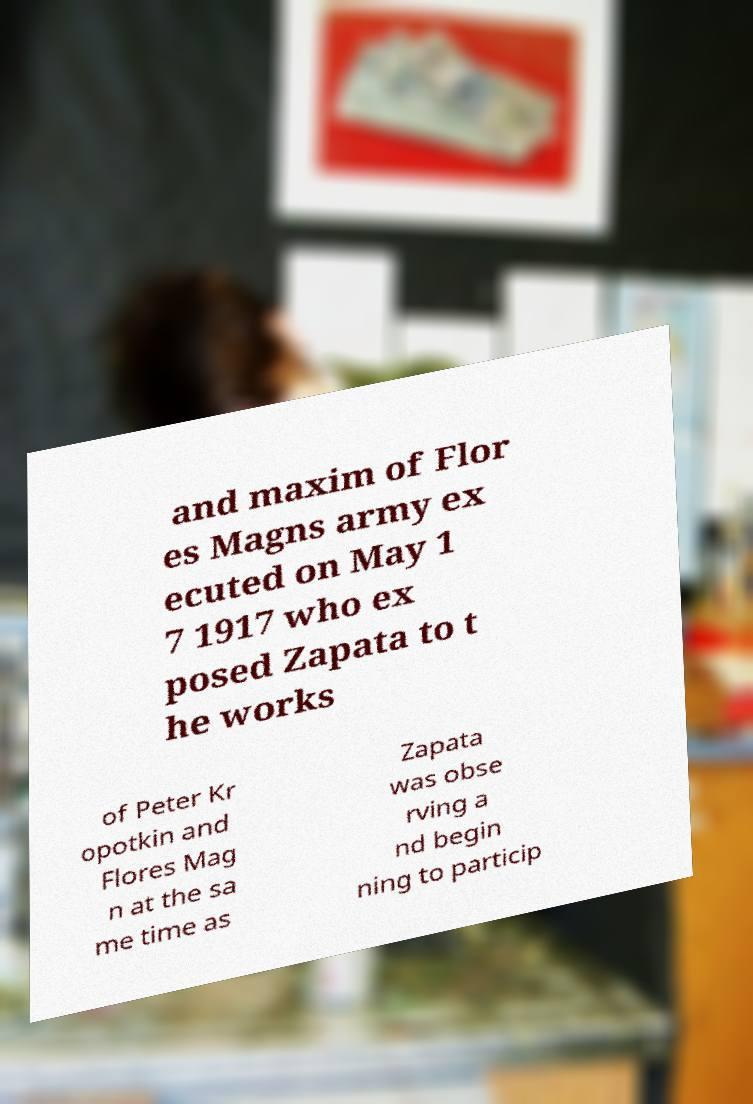There's text embedded in this image that I need extracted. Can you transcribe it verbatim? and maxim of Flor es Magns army ex ecuted on May 1 7 1917 who ex posed Zapata to t he works of Peter Kr opotkin and Flores Mag n at the sa me time as Zapata was obse rving a nd begin ning to particip 